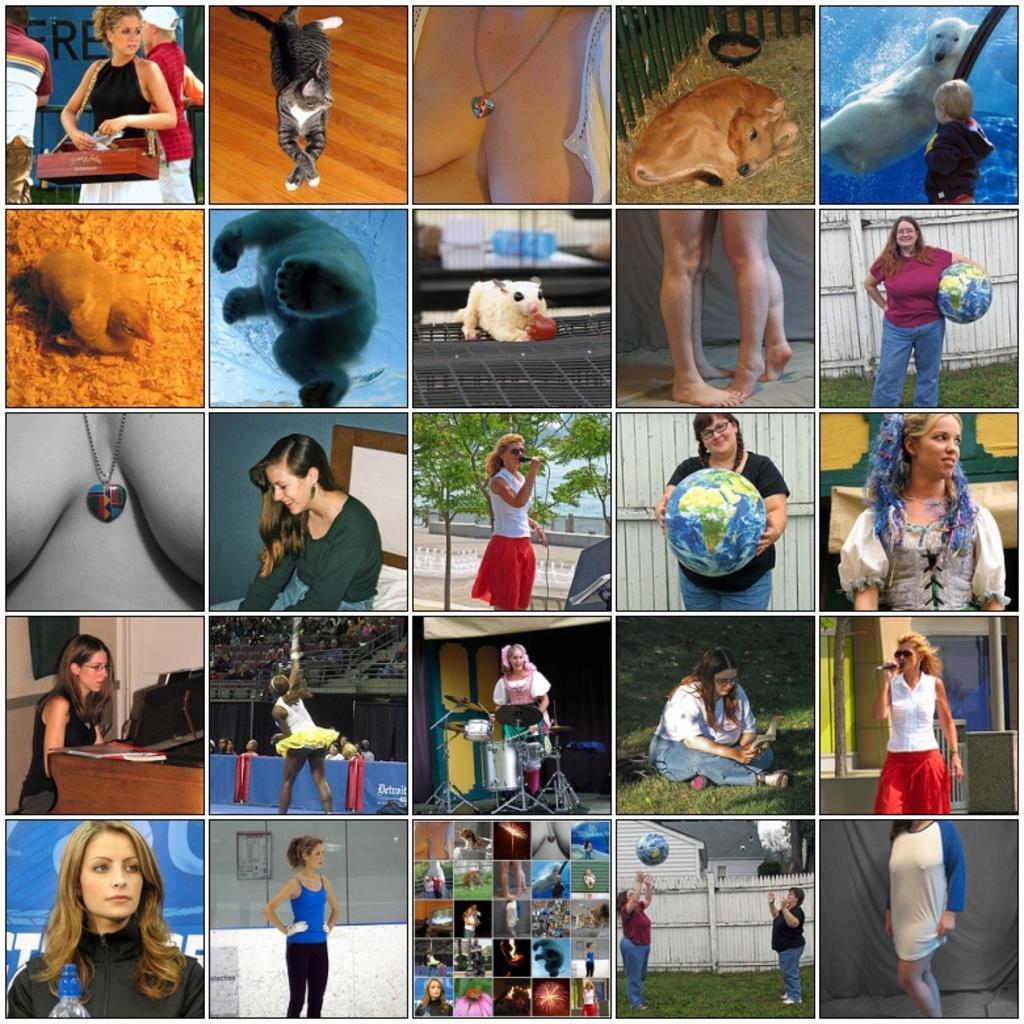Can you describe this image briefly? In this image, there is a collage of photos where we can see persons, animals and lockets. 